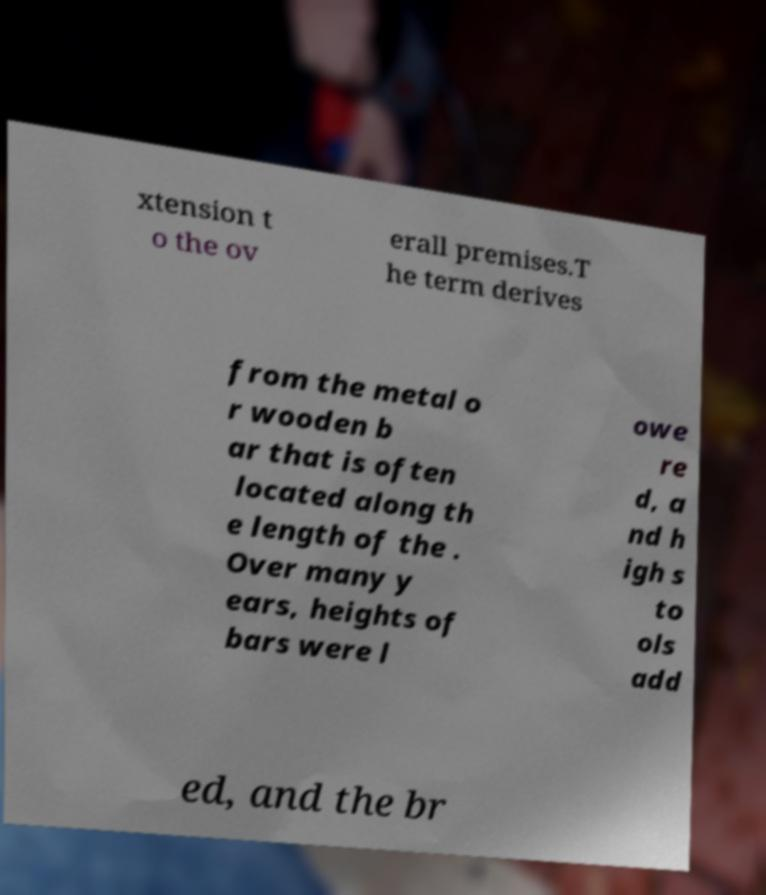There's text embedded in this image that I need extracted. Can you transcribe it verbatim? xtension t o the ov erall premises.T he term derives from the metal o r wooden b ar that is often located along th e length of the . Over many y ears, heights of bars were l owe re d, a nd h igh s to ols add ed, and the br 